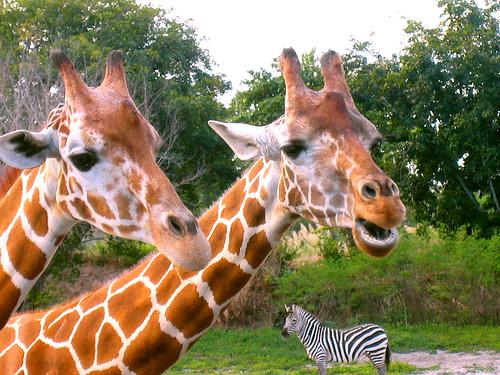What is in front of the zebra?

Choices:
A) dog
B) cat
C) cow
D) giraffe giraffe 